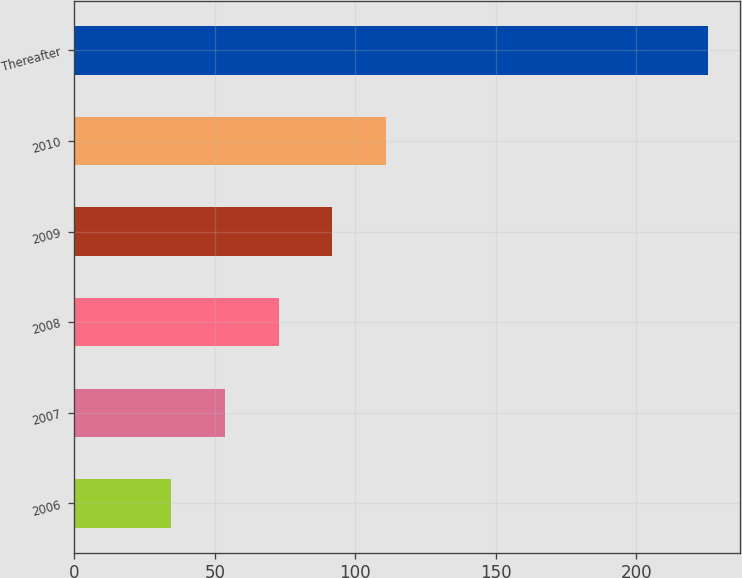Convert chart to OTSL. <chart><loc_0><loc_0><loc_500><loc_500><bar_chart><fcel>2006<fcel>2007<fcel>2008<fcel>2009<fcel>2010<fcel>Thereafter<nl><fcel>34.5<fcel>53.6<fcel>72.7<fcel>91.8<fcel>110.9<fcel>225.5<nl></chart> 